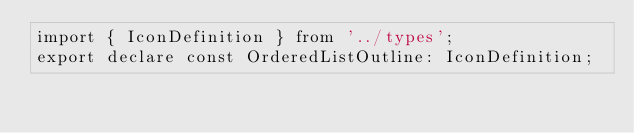Convert code to text. <code><loc_0><loc_0><loc_500><loc_500><_TypeScript_>import { IconDefinition } from '../types';
export declare const OrderedListOutline: IconDefinition;
</code> 